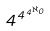<formula> <loc_0><loc_0><loc_500><loc_500>4 ^ { 4 ^ { 4 ^ { \aleph _ { 0 } } } }</formula> 